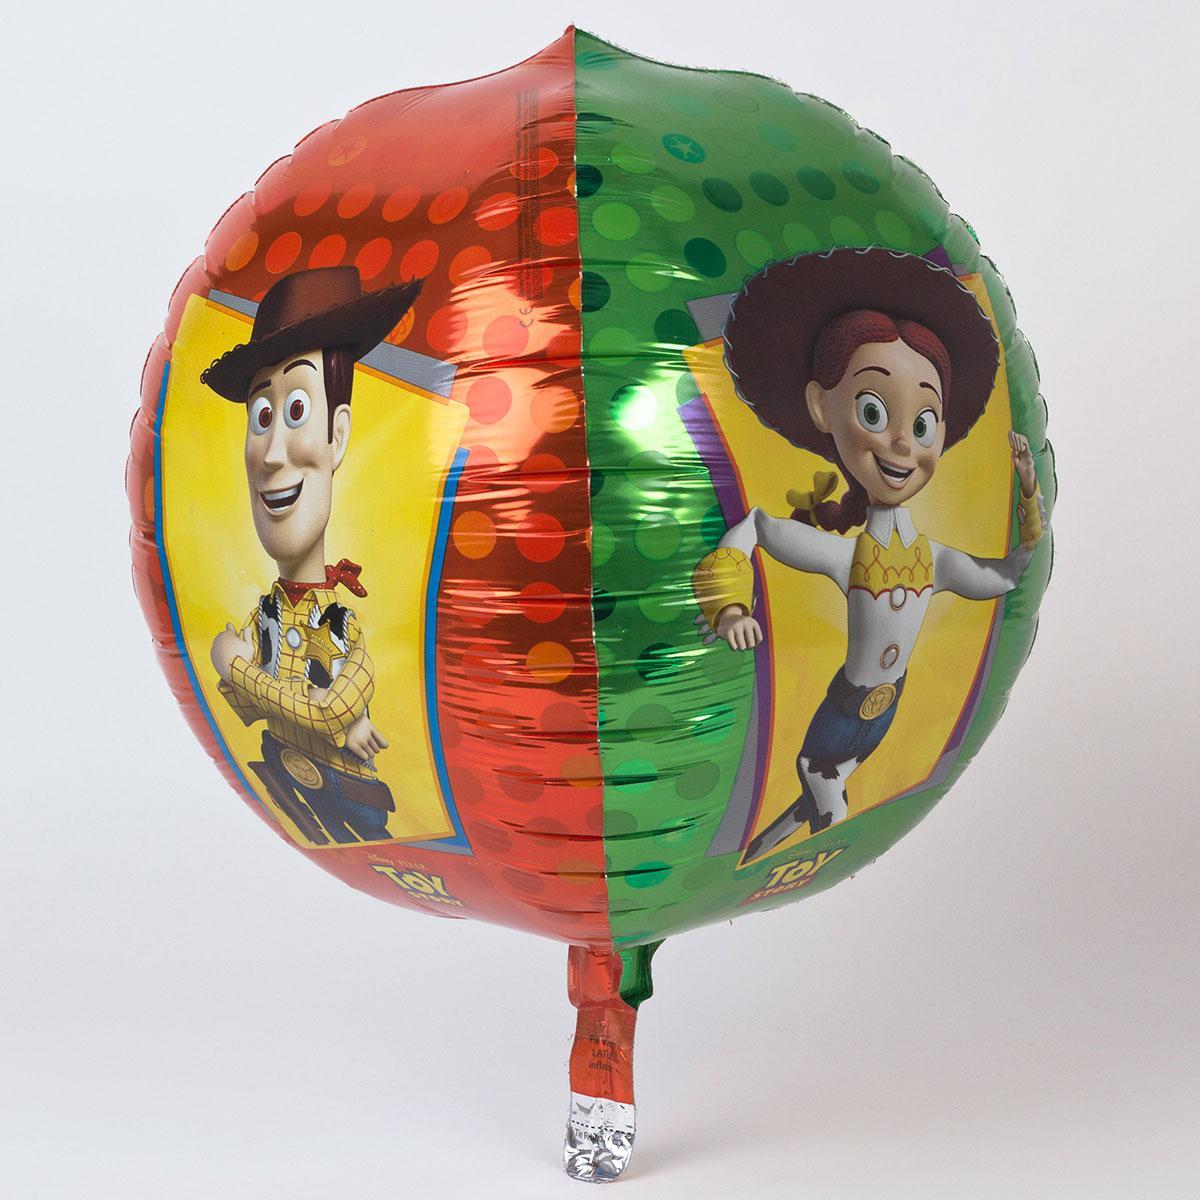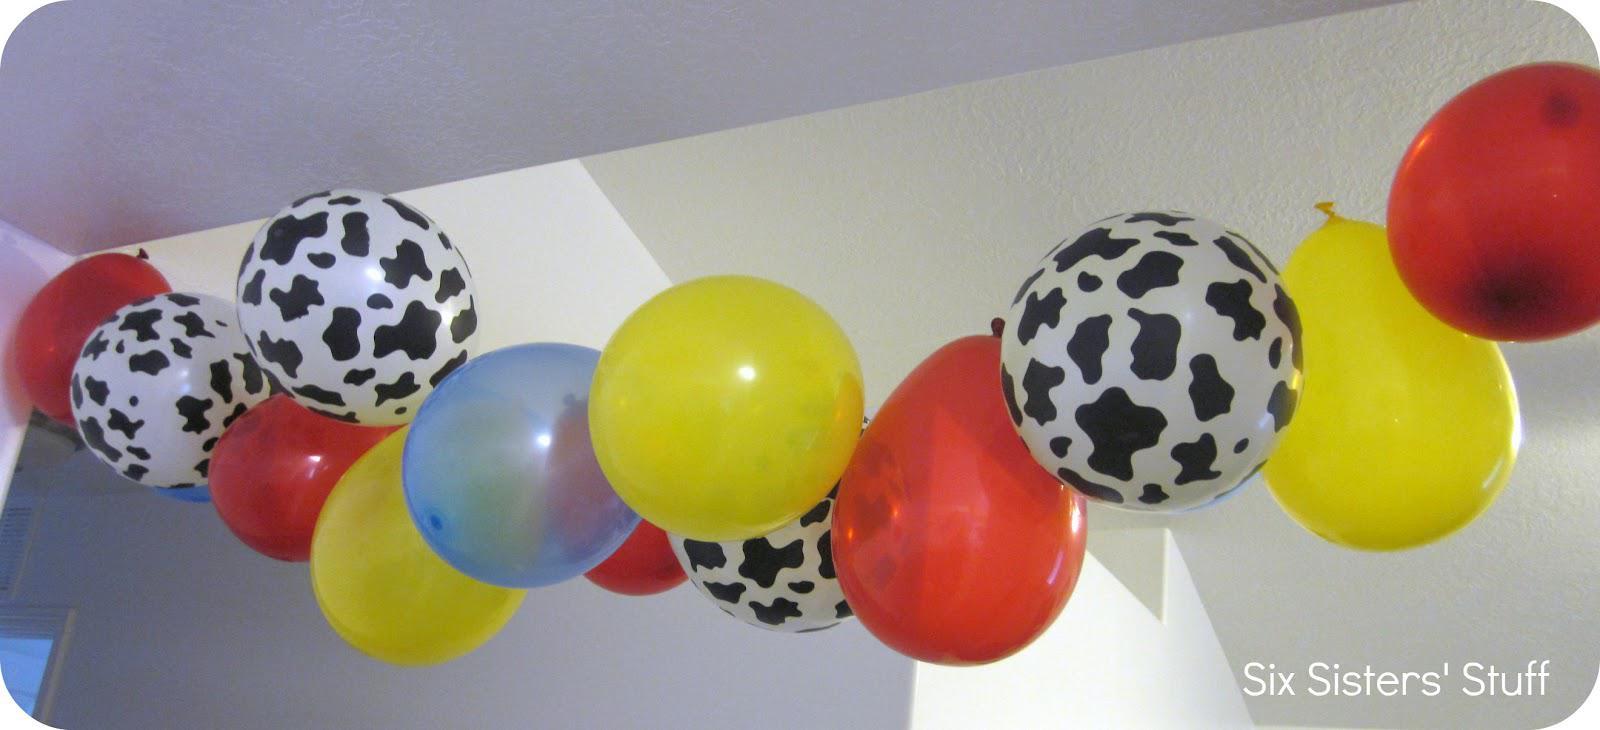The first image is the image on the left, the second image is the image on the right. Considering the images on both sides, is "The right image features a balloon garland hung at the top of a wall and containing at least a dozen balloons." valid? Answer yes or no. Yes. The first image is the image on the left, the second image is the image on the right. Given the left and right images, does the statement "There are exactly three colorful objects in the left image." hold true? Answer yes or no. No. 